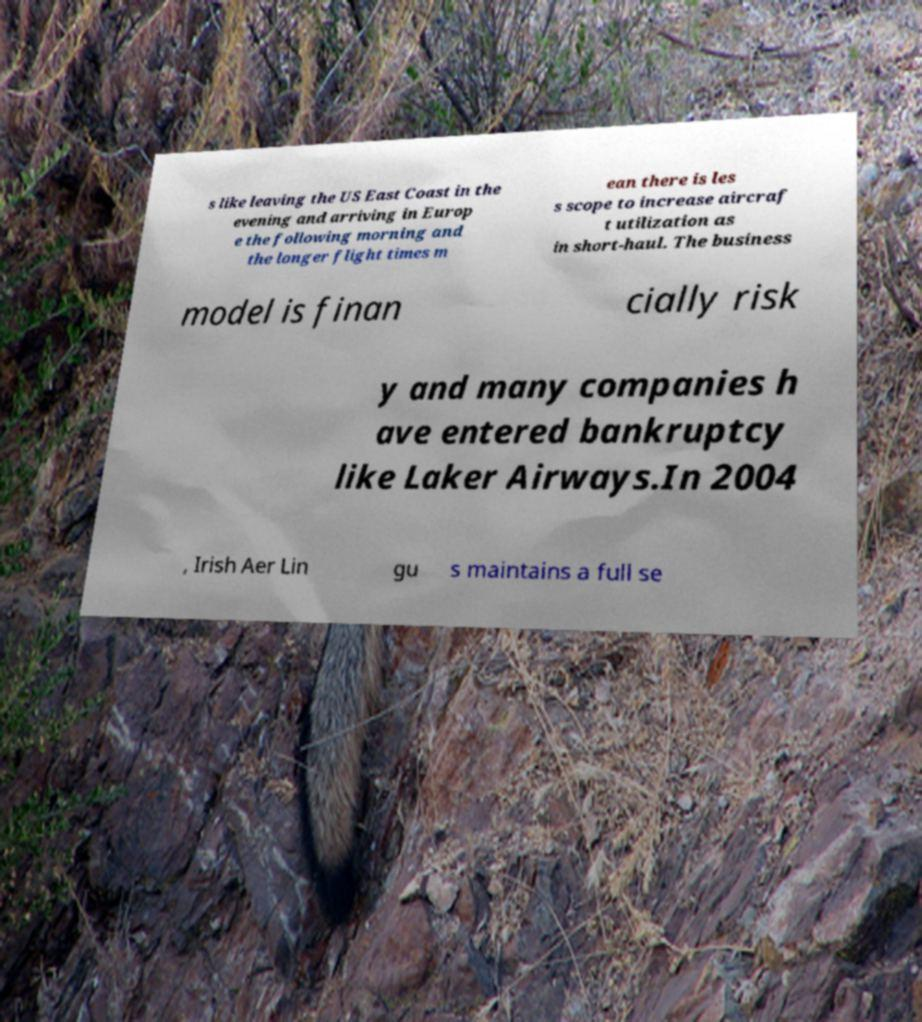Could you assist in decoding the text presented in this image and type it out clearly? s like leaving the US East Coast in the evening and arriving in Europ e the following morning and the longer flight times m ean there is les s scope to increase aircraf t utilization as in short-haul. The business model is finan cially risk y and many companies h ave entered bankruptcy like Laker Airways.In 2004 , Irish Aer Lin gu s maintains a full se 